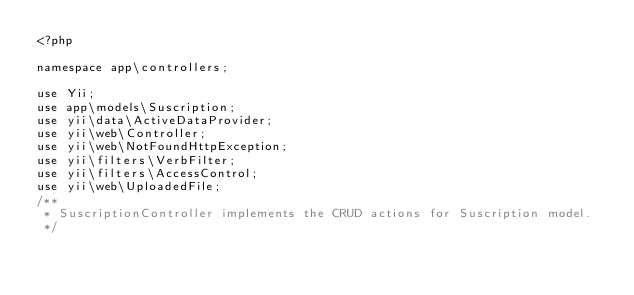Convert code to text. <code><loc_0><loc_0><loc_500><loc_500><_PHP_><?php

namespace app\controllers;

use Yii;
use app\models\Suscription;
use yii\data\ActiveDataProvider;
use yii\web\Controller;
use yii\web\NotFoundHttpException;
use yii\filters\VerbFilter;
use yii\filters\AccessControl;
use yii\web\UploadedFile;
/**
 * SuscriptionController implements the CRUD actions for Suscription model.
 */</code> 